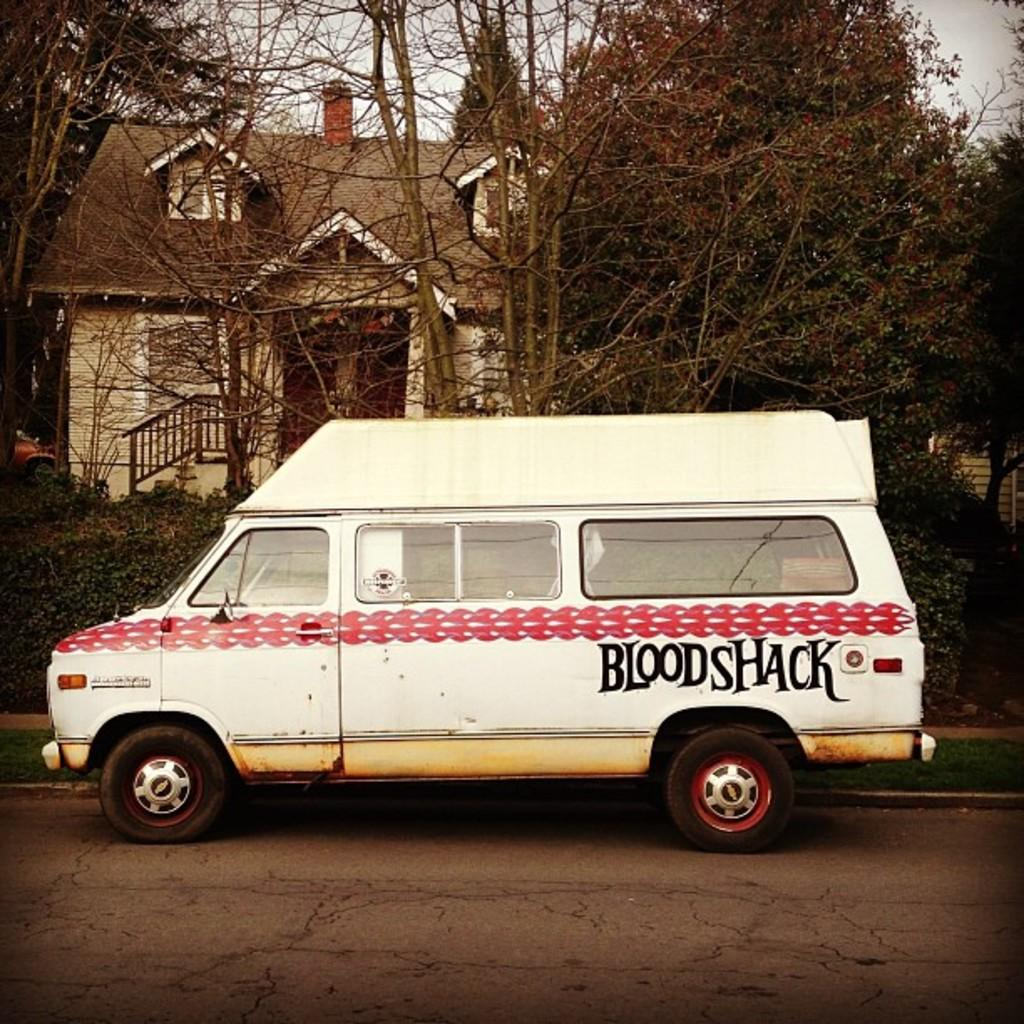What is located in the middle of the road in the image? There is a vehicle parked in the middle of the road in the image. What is the color of the vehicle? The vehicle is white in color. What can be seen at the back side of the image? There is a house at the back side of the image. What type of vegetation is present in the image? There are trees in the image. Where is the table located in the image? There is no table present in the image. What type of insects can be seen crawling on the vehicle in the image? There are no insects, including ants, visible on the vehicle in the image. 